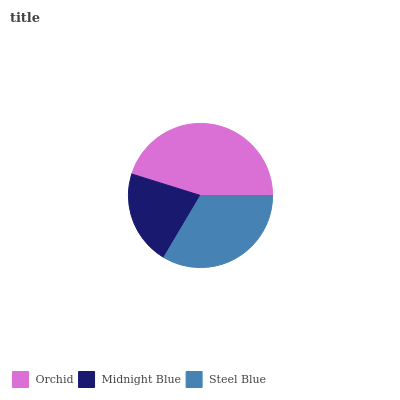Is Midnight Blue the minimum?
Answer yes or no. Yes. Is Orchid the maximum?
Answer yes or no. Yes. Is Steel Blue the minimum?
Answer yes or no. No. Is Steel Blue the maximum?
Answer yes or no. No. Is Steel Blue greater than Midnight Blue?
Answer yes or no. Yes. Is Midnight Blue less than Steel Blue?
Answer yes or no. Yes. Is Midnight Blue greater than Steel Blue?
Answer yes or no. No. Is Steel Blue less than Midnight Blue?
Answer yes or no. No. Is Steel Blue the high median?
Answer yes or no. Yes. Is Steel Blue the low median?
Answer yes or no. Yes. Is Midnight Blue the high median?
Answer yes or no. No. Is Orchid the low median?
Answer yes or no. No. 